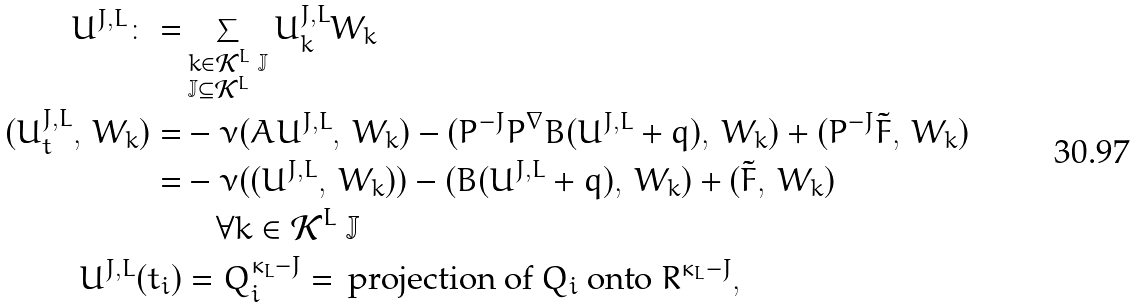<formula> <loc_0><loc_0><loc_500><loc_500>U ^ { J , L } \colon = & \sum _ { \begin{subarray} { l } k \in \mathcal { K } ^ { L } \ \mathbb { J } \\ \mathbb { J } \subseteq \mathcal { K } ^ { L } \end{subarray} } U _ { k } ^ { J , L } W _ { k } \\ ( U ^ { J , L } _ { t } , \, W _ { k } ) = & - \nu ( A U ^ { J , L } , \, W _ { k } ) - ( P ^ { - J } P ^ { \nabla } B ( U ^ { J , L } + q ) , \, W _ { k } ) + ( P ^ { - J } \tilde { F } , \, W _ { k } ) \\ = & - \nu ( ( U ^ { J , L } , \, W _ { k } ) ) - ( B ( U ^ { J , L } + q ) , \, W _ { k } ) + ( \tilde { F } , \, W _ { k } ) \\ & \quad \forall k \in \mathcal { K } ^ { L } \ \mathbb { J } \\ U ^ { J , L } ( t _ { i } ) & = Q _ { i } ^ { \kappa _ { L } - J } = \, \text {projection of $Q_{i}$ onto $\mathbb{ }R^{\kappa_{L}-J}$} ,</formula> 